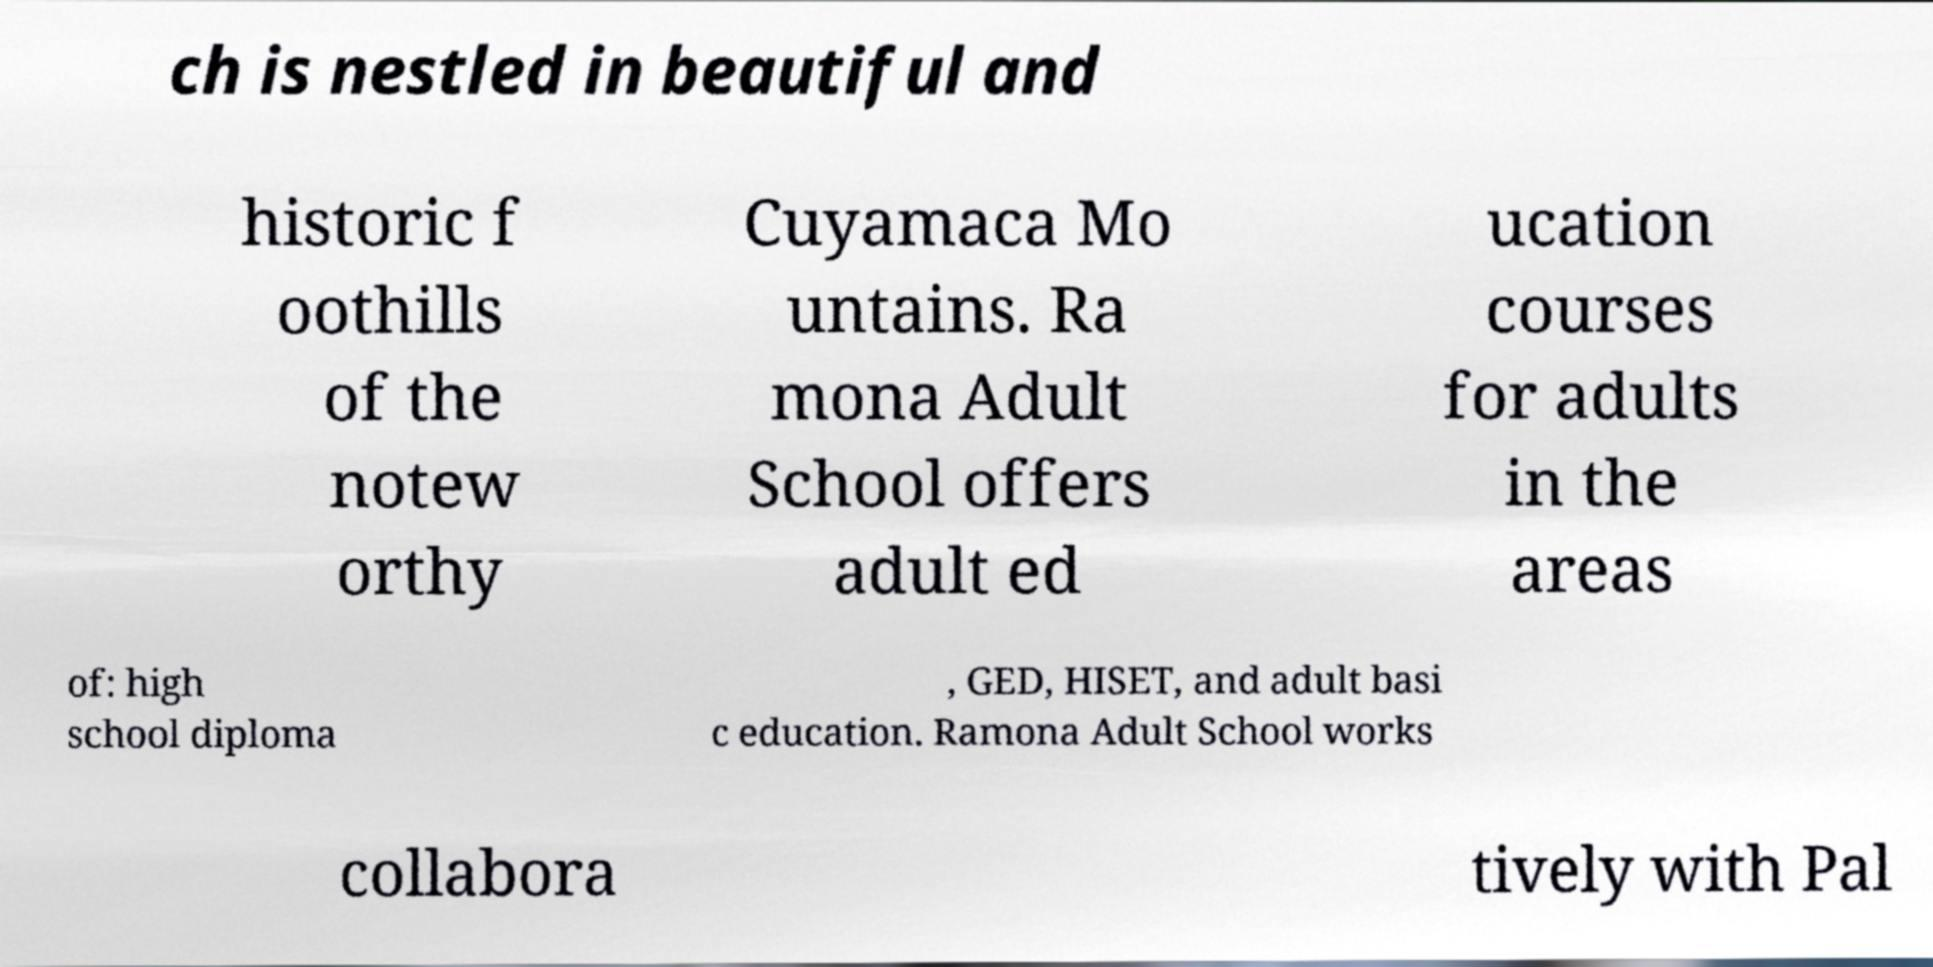I need the written content from this picture converted into text. Can you do that? ch is nestled in beautiful and historic f oothills of the notew orthy Cuyamaca Mo untains. Ra mona Adult School offers adult ed ucation courses for adults in the areas of: high school diploma , GED, HISET, and adult basi c education. Ramona Adult School works collabora tively with Pal 